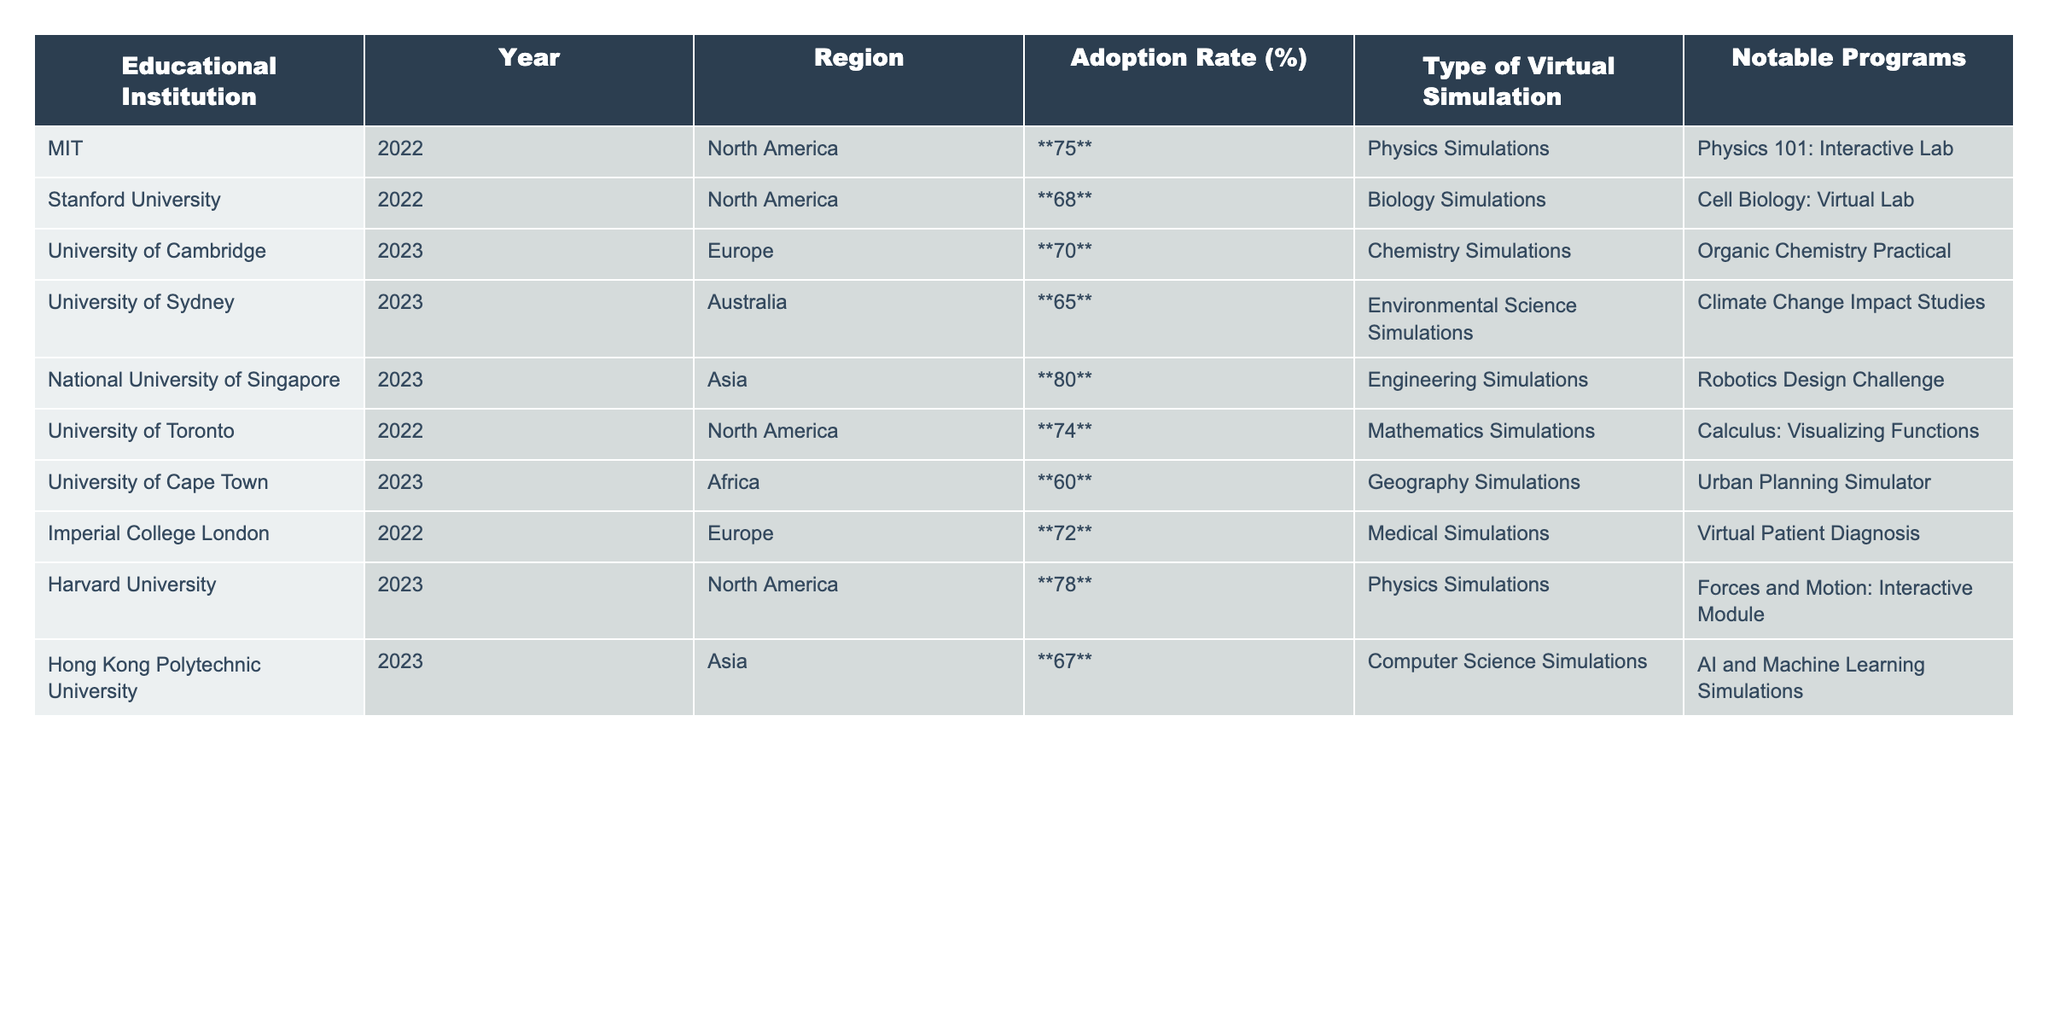What is the highest adoption rate of virtual simulations among the educational institutions listed? The table shows various adoption rates and the highest value is **80** from the National University of Singapore.
Answer: 80 Which educational institution has an adoption rate of **60**%? The University of Cape Town is listed with an adoption rate of **60**%.
Answer: University of Cape Town What is the average adoption rate across all listed institutions? To find the average, sum all adoption rates: (75 + 68 + 70 + 65 + 80 + 74 + 60 + 72 + 78 + 67) = 746. There are 10 institutions, so the average is 746 / 10 = 74.6.
Answer: 74.6 Do more institutions have adoption rates over **70**% than those below **70**%? Four institutions have adoption rates over **70**% (MIT, University of Toronto, Harvard University, and National University of Singapore) and five institutions have rates below **70**% (Stanford, University of Cambridge, University of Sydney, University of Cape Town, and Hong Kong Polytechnic University). Thus, more institutions are below 70%.
Answer: No Which region has the institution with the lowest adoption rate, and what is that rate? The University of Cape Town in Africa has the lowest adoption rate of **60**%.
Answer: Africa, 60 How much higher is the adoption rate of the National University of Singapore compared to the University of Sydney? The National University of Singapore has an adoption rate of **80**% and the University of Sydney has **65**%. The difference is 80 - 65 = **15**%.
Answer: 15 Are there any educational institutions with an adoption rate of **75**%? Yes, MIT has an adoption rate of **75**%.
Answer: Yes What type of virtual simulation does Stanford University use? The table shows that Stanford University uses Biology Simulations.
Answer: Biology Simulations Which two institutions have similar adoption rates, above **70**%? MIT (75%) and University of Toronto (74%) have similar and high adoption rates.
Answer: MIT and University of Toronto Which virtual simulation type has the highest adoption rate and what is that rate? The highest adoption rate of **80**% is associated with Engineering Simulations at the National University of Singapore.
Answer: Engineering Simulations, 80 